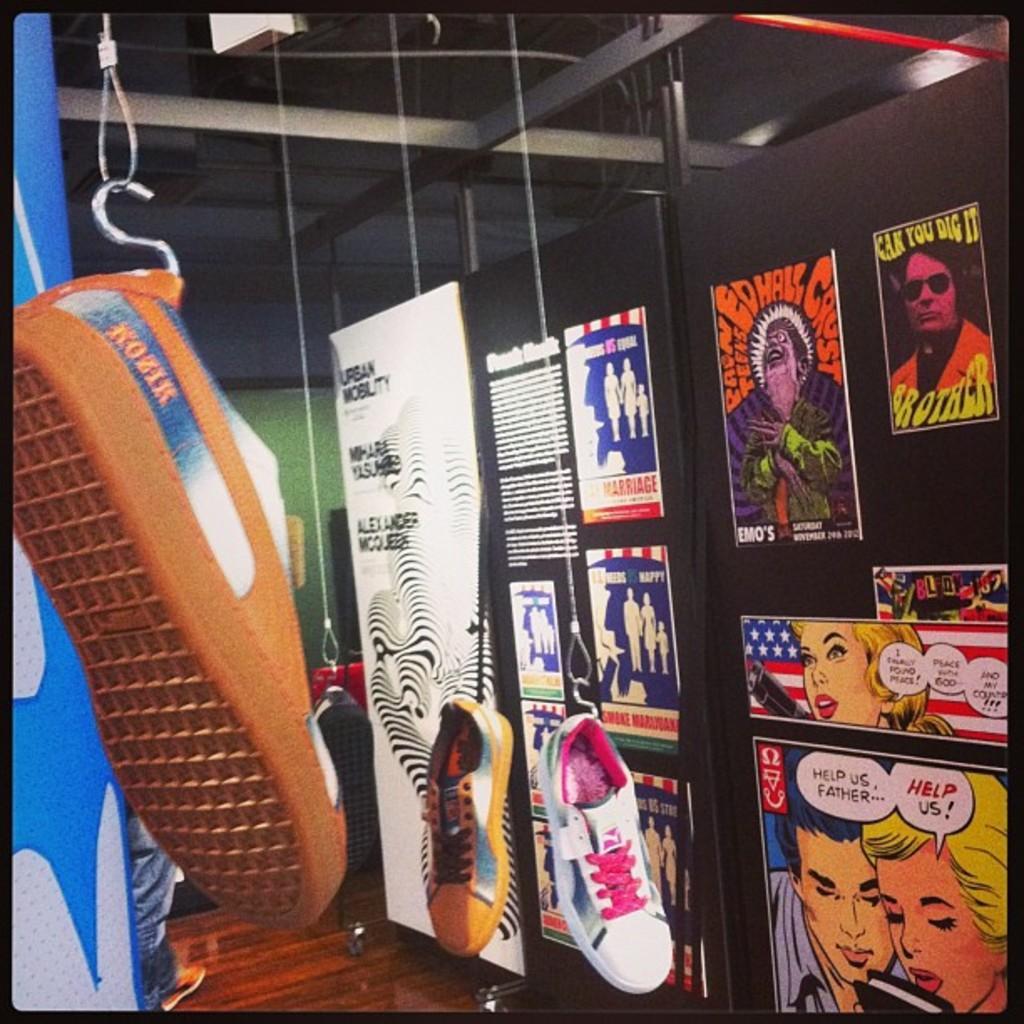Describe this image in one or two sentences. In this image we can see the shoes hanging from the ceiling. We can also see the posters with the images and text and the posters are attached to the black color wall. We can also see the ceiling and also the wall. At the bottom there is floor and there is some person on the left and the image has black color borders. 